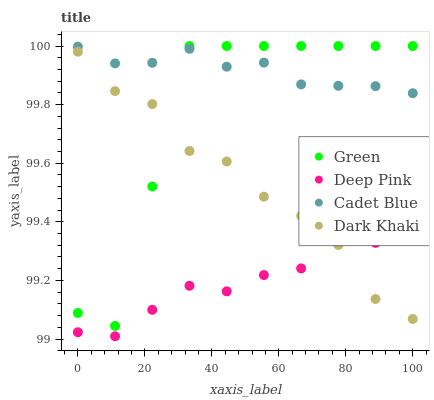Does Deep Pink have the minimum area under the curve?
Answer yes or no. Yes. Does Cadet Blue have the maximum area under the curve?
Answer yes or no. Yes. Does Dark Khaki have the minimum area under the curve?
Answer yes or no. No. Does Dark Khaki have the maximum area under the curve?
Answer yes or no. No. Is Cadet Blue the smoothest?
Answer yes or no. Yes. Is Green the roughest?
Answer yes or no. Yes. Is Dark Khaki the smoothest?
Answer yes or no. No. Is Dark Khaki the roughest?
Answer yes or no. No. Does Deep Pink have the lowest value?
Answer yes or no. Yes. Does Dark Khaki have the lowest value?
Answer yes or no. No. Does Green have the highest value?
Answer yes or no. Yes. Does Dark Khaki have the highest value?
Answer yes or no. No. Is Deep Pink less than Cadet Blue?
Answer yes or no. Yes. Is Cadet Blue greater than Deep Pink?
Answer yes or no. Yes. Does Green intersect Dark Khaki?
Answer yes or no. Yes. Is Green less than Dark Khaki?
Answer yes or no. No. Is Green greater than Dark Khaki?
Answer yes or no. No. Does Deep Pink intersect Cadet Blue?
Answer yes or no. No. 